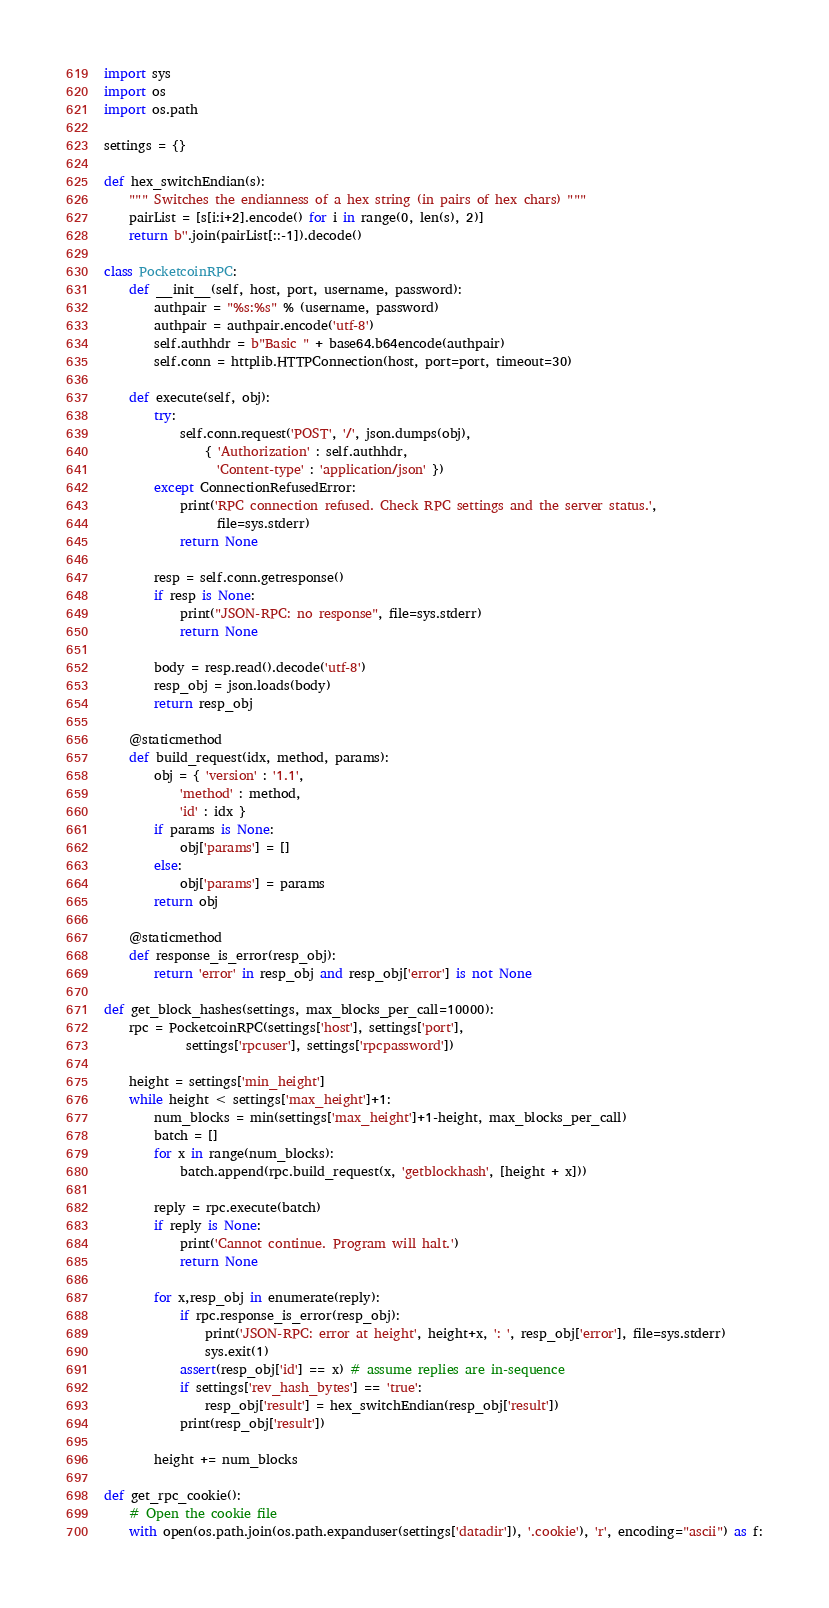<code> <loc_0><loc_0><loc_500><loc_500><_Python_>import sys
import os
import os.path

settings = {}

def hex_switchEndian(s):
    """ Switches the endianness of a hex string (in pairs of hex chars) """
    pairList = [s[i:i+2].encode() for i in range(0, len(s), 2)]
    return b''.join(pairList[::-1]).decode()

class PocketcoinRPC:
    def __init__(self, host, port, username, password):
        authpair = "%s:%s" % (username, password)
        authpair = authpair.encode('utf-8')
        self.authhdr = b"Basic " + base64.b64encode(authpair)
        self.conn = httplib.HTTPConnection(host, port=port, timeout=30)

    def execute(self, obj):
        try:
            self.conn.request('POST', '/', json.dumps(obj),
                { 'Authorization' : self.authhdr,
                  'Content-type' : 'application/json' })
        except ConnectionRefusedError:
            print('RPC connection refused. Check RPC settings and the server status.',
                  file=sys.stderr)
            return None

        resp = self.conn.getresponse()
        if resp is None:
            print("JSON-RPC: no response", file=sys.stderr)
            return None

        body = resp.read().decode('utf-8')
        resp_obj = json.loads(body)
        return resp_obj

    @staticmethod
    def build_request(idx, method, params):
        obj = { 'version' : '1.1',
            'method' : method,
            'id' : idx }
        if params is None:
            obj['params'] = []
        else:
            obj['params'] = params
        return obj

    @staticmethod
    def response_is_error(resp_obj):
        return 'error' in resp_obj and resp_obj['error'] is not None

def get_block_hashes(settings, max_blocks_per_call=10000):
    rpc = PocketcoinRPC(settings['host'], settings['port'],
             settings['rpcuser'], settings['rpcpassword'])

    height = settings['min_height']
    while height < settings['max_height']+1:
        num_blocks = min(settings['max_height']+1-height, max_blocks_per_call)
        batch = []
        for x in range(num_blocks):
            batch.append(rpc.build_request(x, 'getblockhash', [height + x]))

        reply = rpc.execute(batch)
        if reply is None:
            print('Cannot continue. Program will halt.')
            return None

        for x,resp_obj in enumerate(reply):
            if rpc.response_is_error(resp_obj):
                print('JSON-RPC: error at height', height+x, ': ', resp_obj['error'], file=sys.stderr)
                sys.exit(1)
            assert(resp_obj['id'] == x) # assume replies are in-sequence
            if settings['rev_hash_bytes'] == 'true':
                resp_obj['result'] = hex_switchEndian(resp_obj['result'])
            print(resp_obj['result'])

        height += num_blocks

def get_rpc_cookie():
    # Open the cookie file
    with open(os.path.join(os.path.expanduser(settings['datadir']), '.cookie'), 'r', encoding="ascii") as f:</code> 